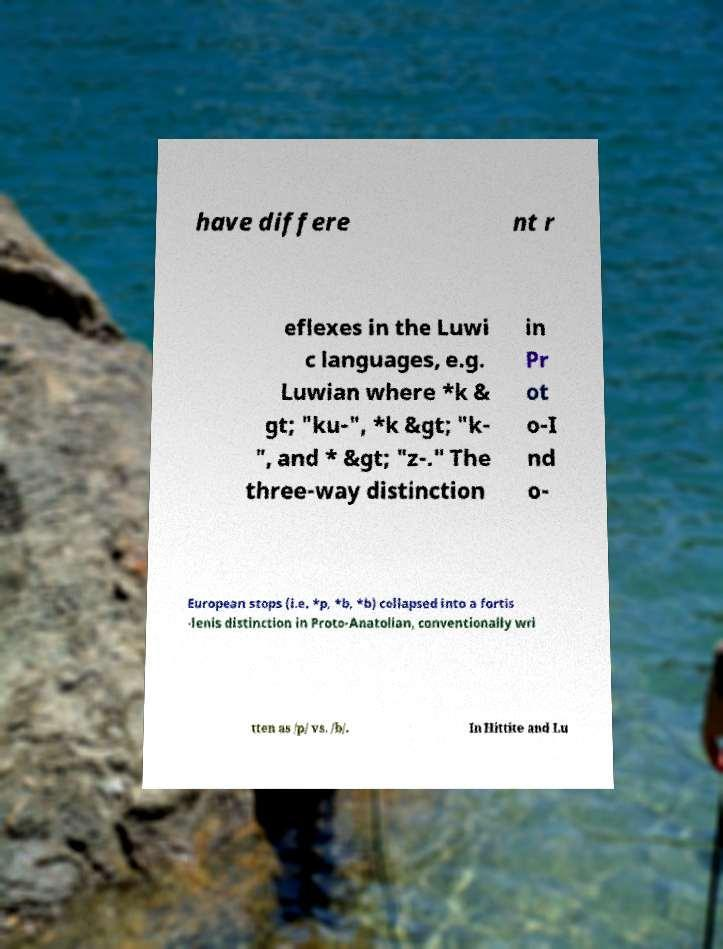Please read and relay the text visible in this image. What does it say? have differe nt r eflexes in the Luwi c languages, e.g. Luwian where *k & gt; "ku-", *k &gt; "k- ", and * &gt; "z-." The three-way distinction in Pr ot o-I nd o- European stops (i.e. *p, *b, *b) collapsed into a fortis -lenis distinction in Proto-Anatolian, conventionally wri tten as /p/ vs. /b/. In Hittite and Lu 